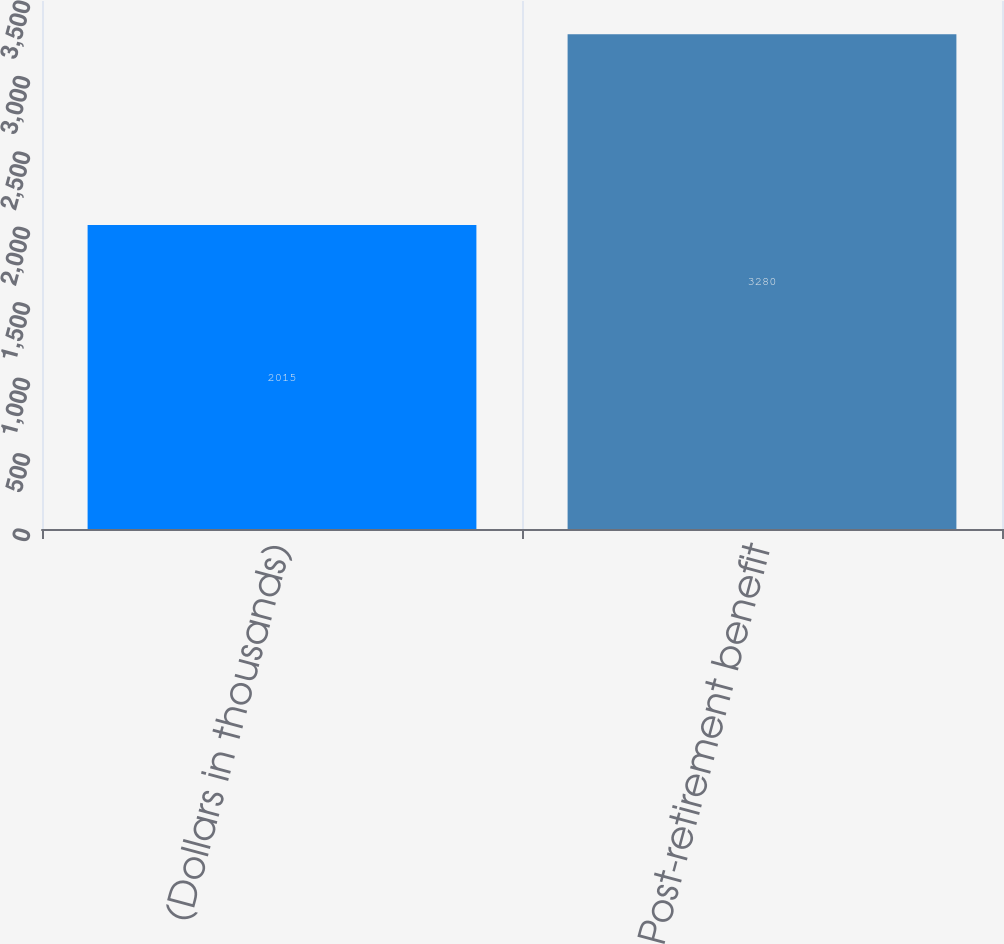Convert chart to OTSL. <chart><loc_0><loc_0><loc_500><loc_500><bar_chart><fcel>(Dollars in thousands)<fcel>Post-retirement benefit<nl><fcel>2015<fcel>3280<nl></chart> 